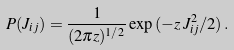Convert formula to latex. <formula><loc_0><loc_0><loc_500><loc_500>P ( J _ { i j } ) = \frac { 1 } { ( 2 \pi z ) ^ { 1 / 2 } } \exp { ( - z \, J _ { i j } ^ { 2 } / 2 ) } \, .</formula> 